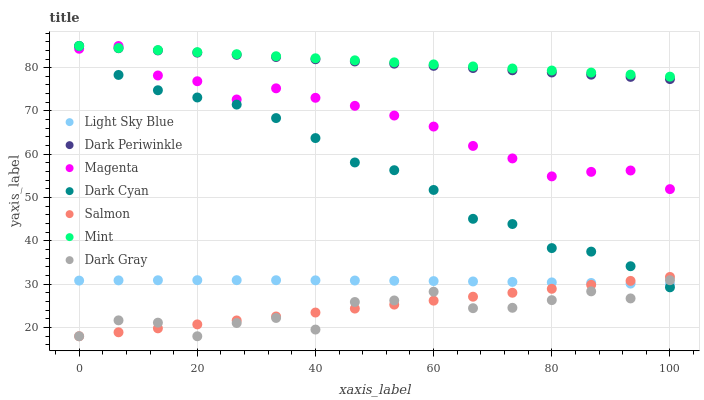Does Dark Gray have the minimum area under the curve?
Answer yes or no. Yes. Does Mint have the maximum area under the curve?
Answer yes or no. Yes. Does Light Sky Blue have the minimum area under the curve?
Answer yes or no. No. Does Light Sky Blue have the maximum area under the curve?
Answer yes or no. No. Is Salmon the smoothest?
Answer yes or no. Yes. Is Dark Gray the roughest?
Answer yes or no. Yes. Is Light Sky Blue the smoothest?
Answer yes or no. No. Is Light Sky Blue the roughest?
Answer yes or no. No. Does Salmon have the lowest value?
Answer yes or no. Yes. Does Light Sky Blue have the lowest value?
Answer yes or no. No. Does Dark Periwinkle have the highest value?
Answer yes or no. Yes. Does Light Sky Blue have the highest value?
Answer yes or no. No. Is Dark Gray less than Mint?
Answer yes or no. Yes. Is Dark Periwinkle greater than Dark Gray?
Answer yes or no. Yes. Does Dark Cyan intersect Dark Periwinkle?
Answer yes or no. Yes. Is Dark Cyan less than Dark Periwinkle?
Answer yes or no. No. Is Dark Cyan greater than Dark Periwinkle?
Answer yes or no. No. Does Dark Gray intersect Mint?
Answer yes or no. No. 